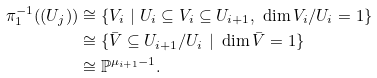<formula> <loc_0><loc_0><loc_500><loc_500>\pi _ { 1 } ^ { - 1 } ( ( U _ { j } ) ) & \cong \{ V _ { i } \ | \ U _ { i } \subseteq V _ { i } \subseteq U _ { i + 1 } , \ \dim V _ { i } / U _ { i } = 1 \} \\ & \cong \{ \bar { V } \subseteq U _ { i + 1 } / U _ { i } \ | \ \dim \bar { V } = 1 \} \\ & \cong \mathbb { P } ^ { \mu _ { i + 1 } - 1 } .</formula> 